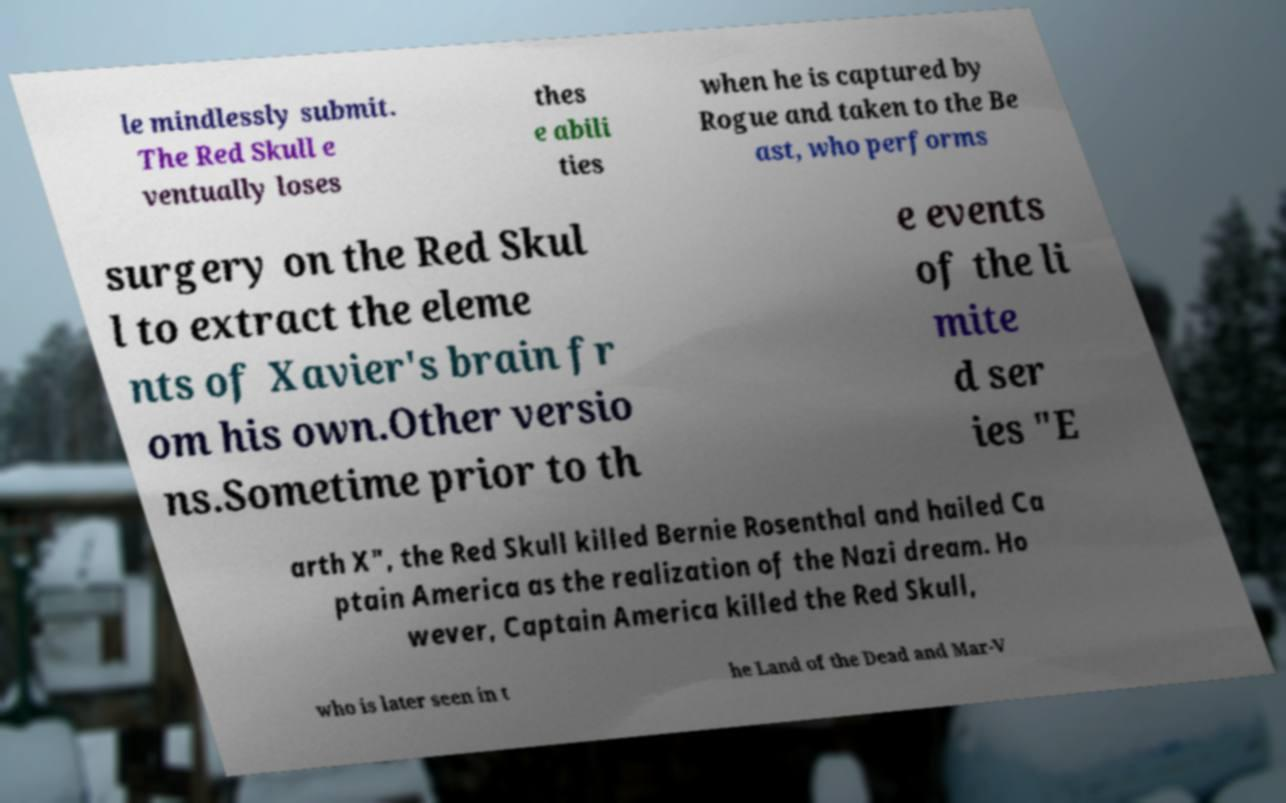What messages or text are displayed in this image? I need them in a readable, typed format. le mindlessly submit. The Red Skull e ventually loses thes e abili ties when he is captured by Rogue and taken to the Be ast, who performs surgery on the Red Skul l to extract the eleme nts of Xavier's brain fr om his own.Other versio ns.Sometime prior to th e events of the li mite d ser ies "E arth X", the Red Skull killed Bernie Rosenthal and hailed Ca ptain America as the realization of the Nazi dream. Ho wever, Captain America killed the Red Skull, who is later seen in t he Land of the Dead and Mar-V 